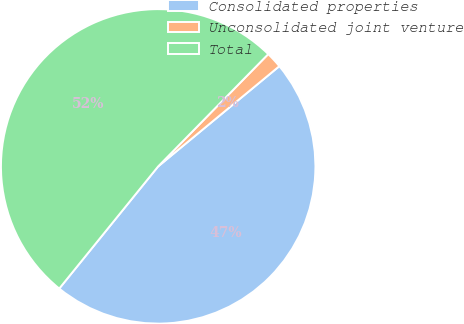Convert chart. <chart><loc_0><loc_0><loc_500><loc_500><pie_chart><fcel>Consolidated properties<fcel>Unconsolidated joint venture<fcel>Total<nl><fcel>46.83%<fcel>1.66%<fcel>51.51%<nl></chart> 